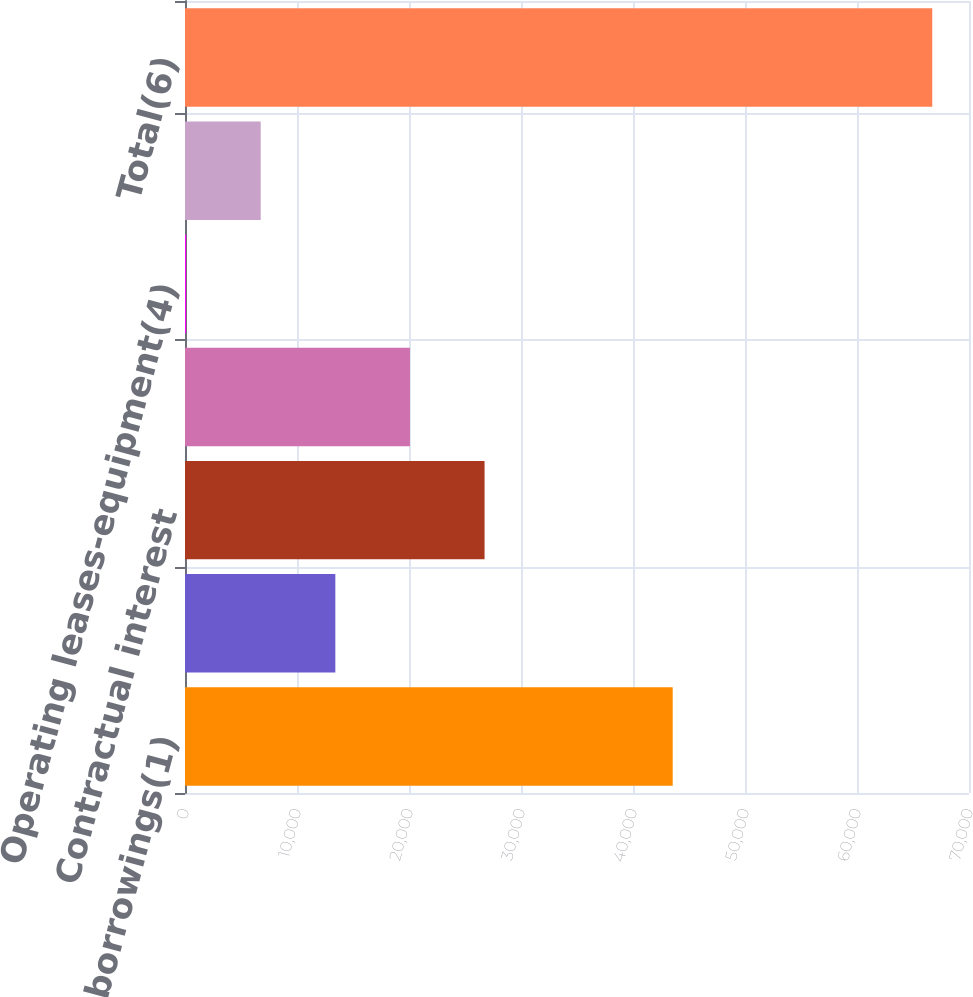<chart> <loc_0><loc_0><loc_500><loc_500><bar_chart><fcel>Long-term borrowings(1)<fcel>Other secured financings(1)<fcel>Contractual interest<fcel>Operating leases-office<fcel>Operating leases-equipment(4)<fcel>Purchase obligations(5)<fcel>Total(6)<nl><fcel>43545<fcel>13422.4<fcel>26746.8<fcel>20084.6<fcel>98<fcel>6760.2<fcel>66720<nl></chart> 